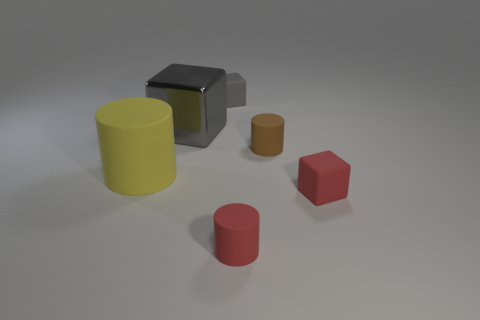What number of things are either rubber things that are in front of the large rubber object or red rubber objects on the right side of the brown cylinder?
Your answer should be compact. 2. There is a tiny rubber cylinder that is right of the small red matte cylinder; what color is it?
Make the answer very short. Brown. Are there any gray shiny blocks to the right of the small matte cube that is left of the small brown cylinder?
Give a very brief answer. No. Is the number of tiny brown rubber objects less than the number of tiny cylinders?
Provide a short and direct response. Yes. What is the tiny object that is left of the tiny rubber cylinder that is in front of the big matte cylinder made of?
Provide a succinct answer. Rubber. Do the red cylinder and the gray rubber cube have the same size?
Make the answer very short. Yes. What number of objects are either large balls or small red rubber cubes?
Give a very brief answer. 1. What size is the thing that is both left of the small brown object and in front of the yellow cylinder?
Provide a succinct answer. Small. Are there fewer big yellow rubber objects that are behind the small brown matte object than big yellow cylinders?
Ensure brevity in your answer.  Yes. What is the shape of the yellow thing that is the same material as the tiny gray cube?
Give a very brief answer. Cylinder. 